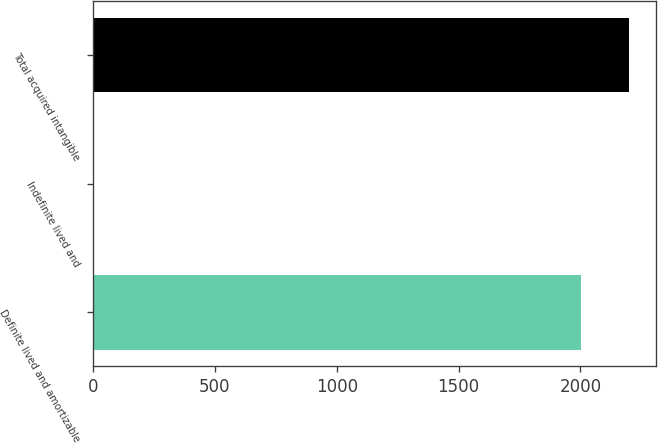<chart> <loc_0><loc_0><loc_500><loc_500><bar_chart><fcel>Definite lived and amortizable<fcel>Indefinite lived and<fcel>Total acquired intangible<nl><fcel>2002<fcel>4.69<fcel>2201.73<nl></chart> 